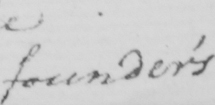What does this handwritten line say? founder ' s 